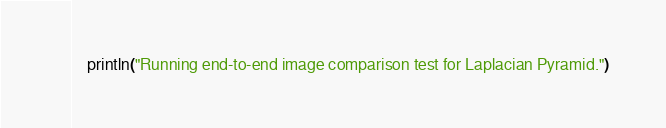Convert code to text. <code><loc_0><loc_0><loc_500><loc_500><_Julia_>    println("Running end-to-end image comparison test for Laplacian Pyramid.")</code> 